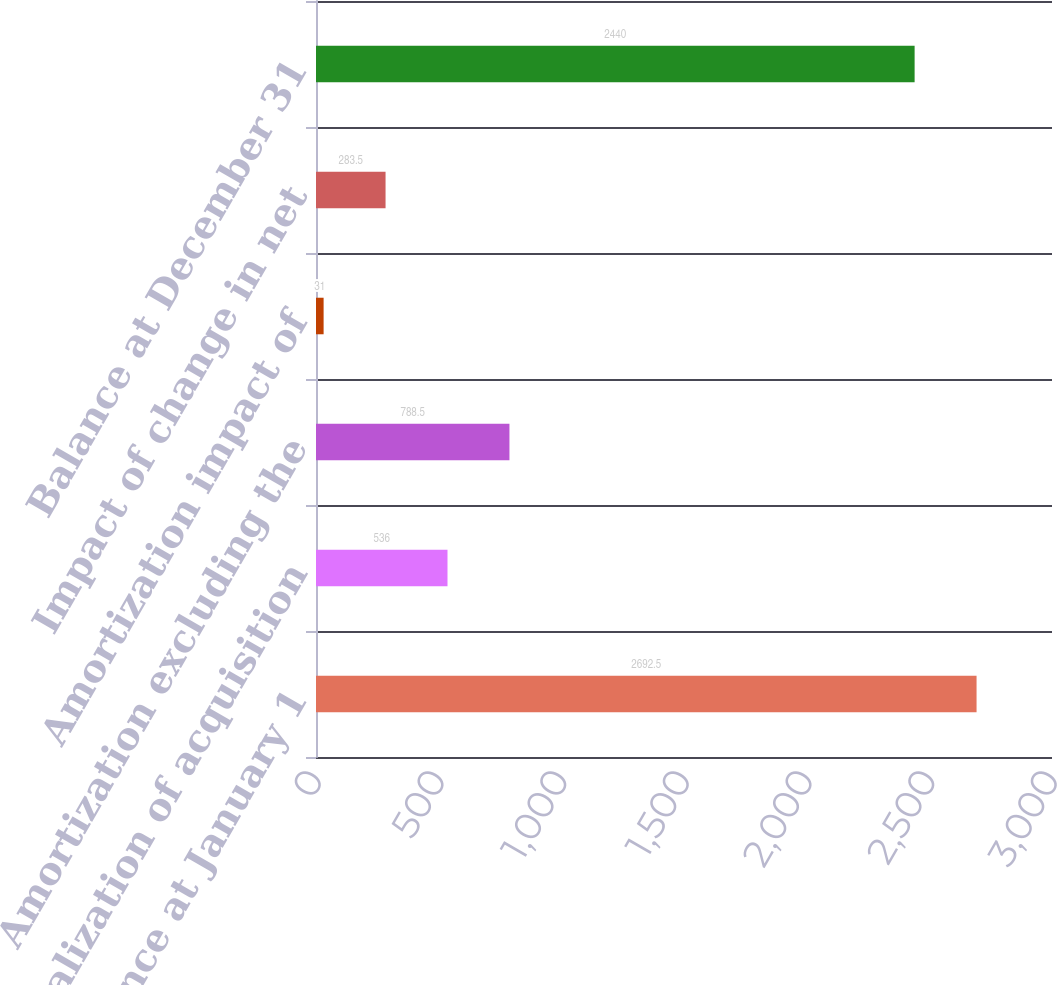Convert chart. <chart><loc_0><loc_0><loc_500><loc_500><bar_chart><fcel>Balance at January 1<fcel>Capitalization of acquisition<fcel>Amortization excluding the<fcel>Amortization impact of<fcel>Impact of change in net<fcel>Balance at December 31<nl><fcel>2692.5<fcel>536<fcel>788.5<fcel>31<fcel>283.5<fcel>2440<nl></chart> 